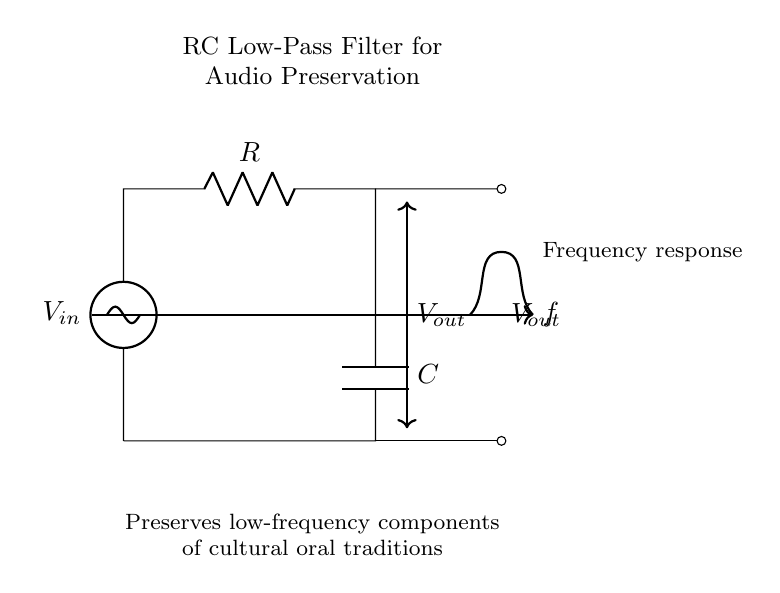What is the input voltage of this circuit? The input voltage, labeled as \( V_{in} \), is represented on the left side of the diagram. It is the source voltage connecting to the circuit.
Answer: \( V_{in} \) What components are present in this RC filter circuit? The circuit contains a resistor, \( R \), and a capacitor, \( C \), which are essential components of an RC filter, along with the voltage sources and connections.
Answer: Resistor and Capacitor What does \( V_{out} \) represent? \( V_{out} \) is the output voltage of the circuit and is depicted on the right side, where the signal after filtering is taken from.
Answer: Output voltage What is the purpose of the RC low-pass filter in this circuit? The purpose of the RC low-pass filter is to preserve the low-frequency components of audio signals, particularly beneficial for capturing cultural oral traditions.
Answer: Preserve low frequencies How does the value of the resistor affect the filter's cutoff frequency? The cutoff frequency of the filter is inversely proportional to the resistance. A higher resistance results in a lower cutoff frequency, allowing fewer high frequencies to pass.
Answer: Inversely proportional What happens to high-frequency signals in this RC filter? High-frequency signals are attenuated or reduced in magnitude as they are filtered out by the RC circuit, resulting in only low-frequency signals passing through.
Answer: Attenuated Which type of filter is this circuit classified as? This circuit is classified as a low-pass filter because it allows low-frequency signals to pass while blocking high-frequency signals.
Answer: Low-pass filter 